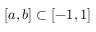Convert formula to latex. <formula><loc_0><loc_0><loc_500><loc_500>[ a , b ] \subset [ - 1 , 1 ]</formula> 